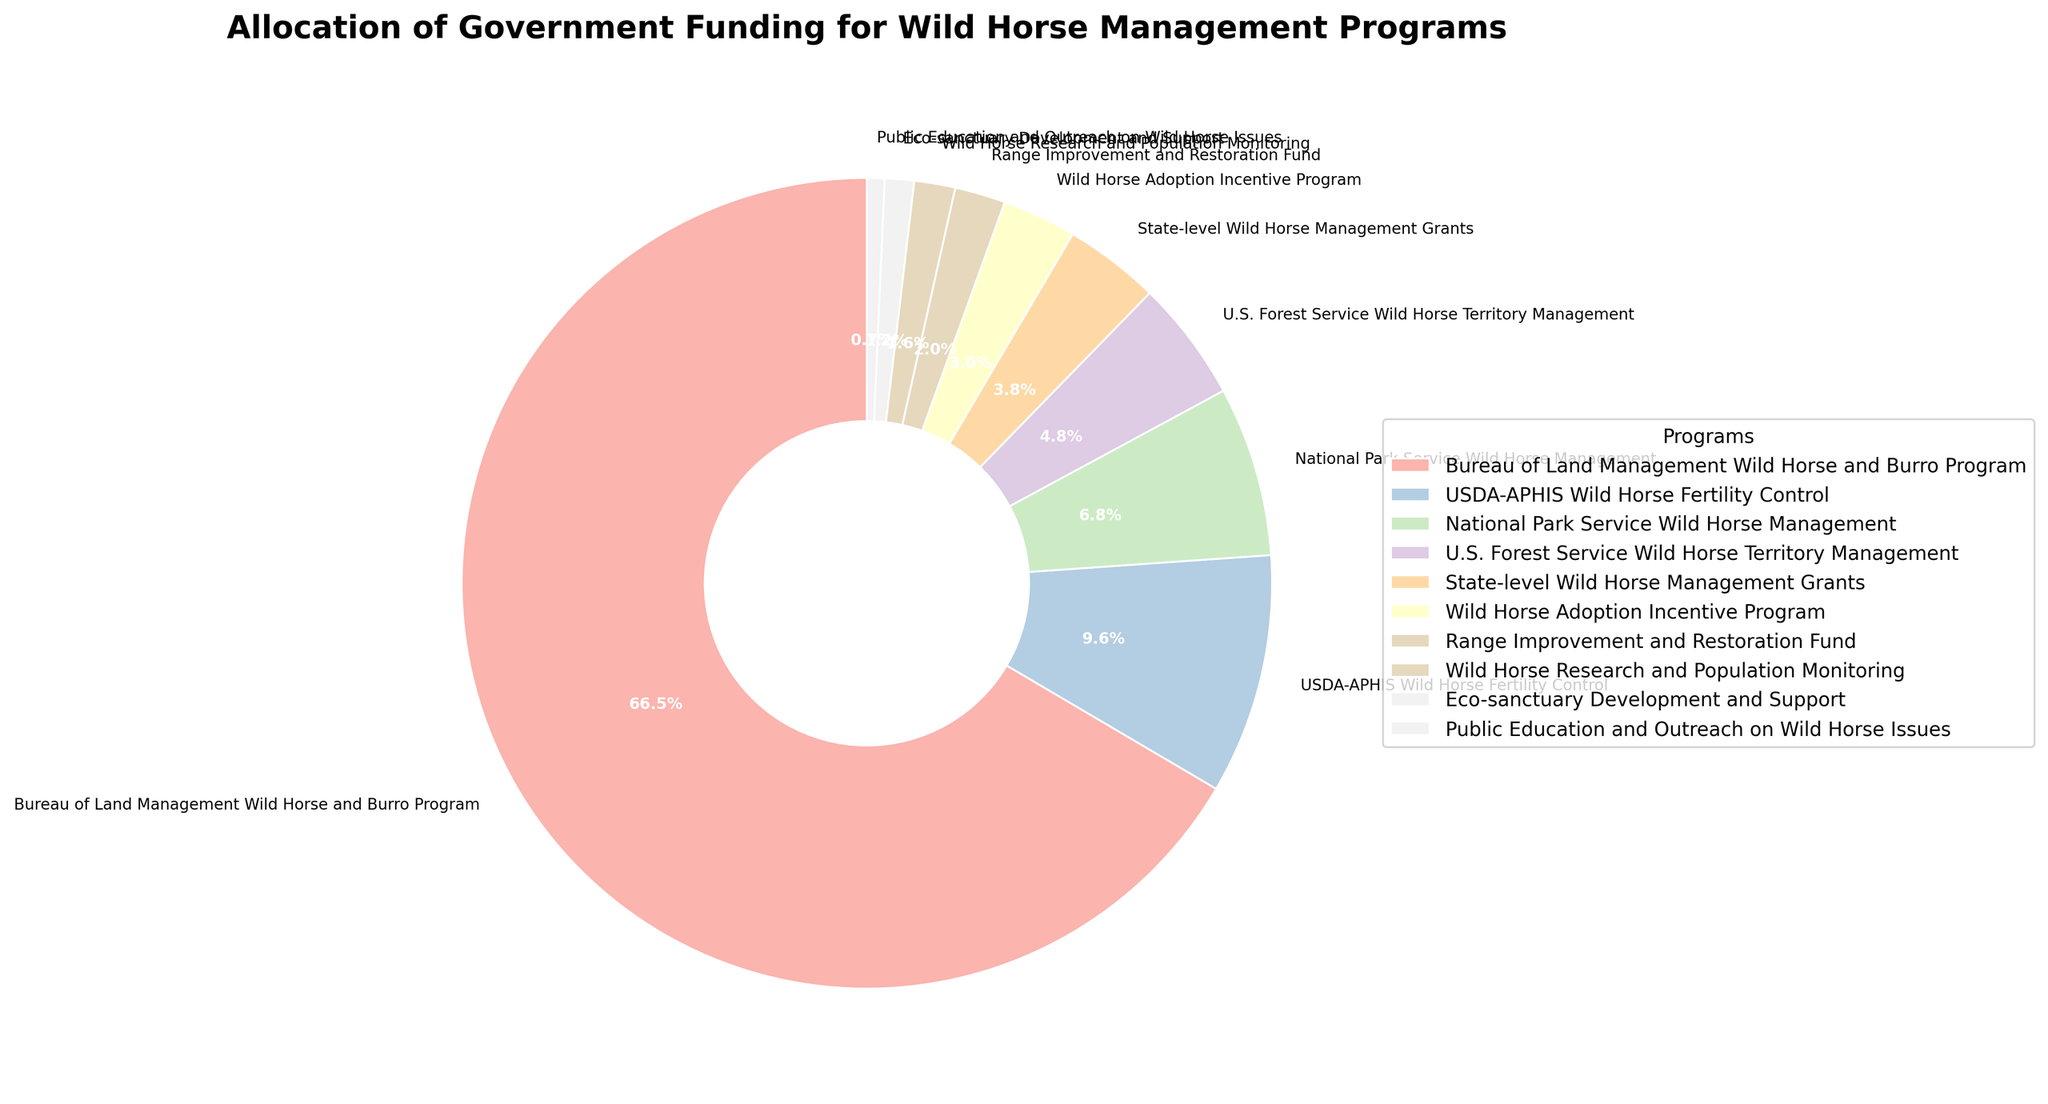what percentage of the funding is allocated to the Bureau of Land Management Wild Horse and Burro Program? The pie chart shows the presentation of each program, and the Bureau of Land Management Wild Horse and Burro Program's segment is labeled with its percentage. Locate the segment and read the percentage, which is clearly marked.
Answer: 70.4% How does the funding for the USDA-APHIS Wild Horse Fertility Control compare to the funding for the State-level Wild Horse Management Grants? The pie chart segments for each program have labels showing the allocation in percentages. Compare the segments for USDA-APHIS Wild Horse Fertility Control and State-level Wild Horse Management Grants to see which is larger and by how much.
Answer: USDA-APHIS Wild Horse Fertility Control receives more funding What is the combined percentage of funding for the National Park Service Wild Horse Management and U.S. Forest Service Wild Horse Territory Management? Identify the segments for National Park Service Wild Horse Management and U.S. Forest Service Wild Horse Territory Management in the pie chart. Add their percentages together to get the combined funding percentage.
Answer: 12.7% Which program receives the smallest amount of funding, and what percentage does it represent? Look for the smallest segment in the pie chart. The smallest segment will correspond to the smallest amount of funding. Read the percentage label for this segment.
Answer: Public Education and Outreach on Wild Horse Issues, 0.7% What is the total allocation for all programs except the Bureau of Land Management Wild Horse and Burro Program? First, find the percentage for the Bureau of Land Management Wild Horse and Burro Program. Subtract this percentage from 100% to find the combined percentage of the remaining segments.
Answer: 29.6% Which program has a funding allocation closest to three times the amount allocated to the Wild Horse Research and Population Monitoring? Find the segment for Wild Horse Research and Population Monitoring and read its percentage. Calculate 3 times this percentage. Look for the segment whose percentage is closest to this value.
Answer: Wild Horse Adoption Incentive Program What are the two programs with the most similar funding allocations, and what are their percentages? Observe the pie chart to identify segments that appear nearly equal in size. Read the labels for these two segments to get their percentages.
Answer: Range Improvement and Restoration Fund, Wild Horse Research and Population Monitoring (2.1% and 1.5%) What's the difference in percentage between the funding for Eco-sanctuary Development and Support and the Wild Horse Research and Population Monitoring? Read the percentage for each of these two segments from the chart. Subtract the smaller percentage from the larger one to find the difference.
Answer: 0.6% If the funding for the Wild Horse Adoption Incentive Program was doubled, what percentage of the total funding would it represent? Find the current funding percentage for Wild Horse Adoption Incentive Program. Double this percentage, and this result represents the new percentage of the total funding if the program's funding was doubled.
Answer: 6.1% 